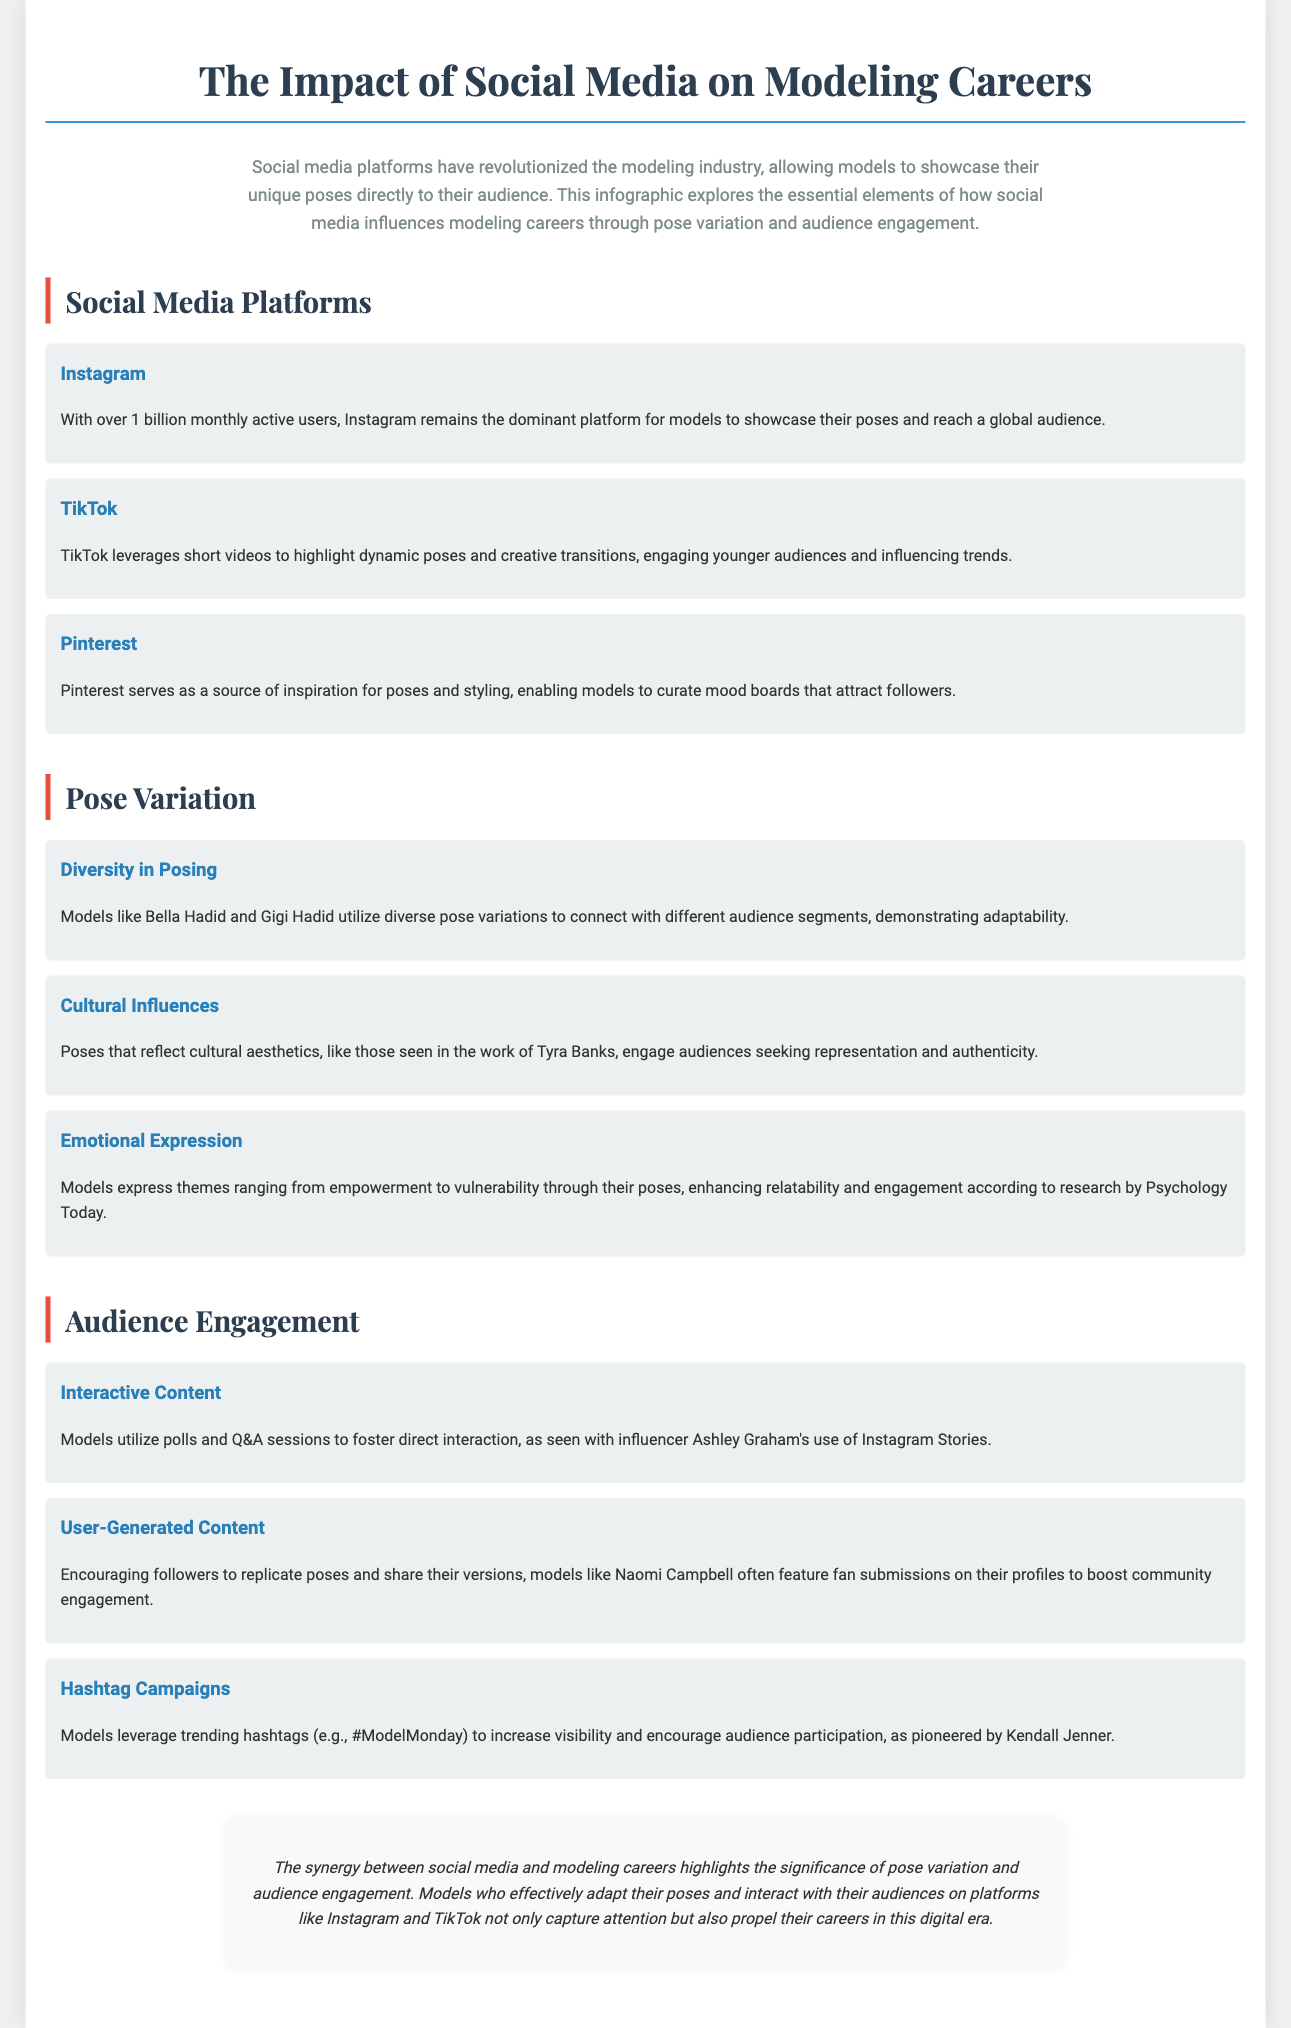what is the dominant platform for models to showcase their poses? The document states that Instagram remains the dominant platform for models with over 1 billion monthly active users.
Answer: Instagram who are two models mentioned that utilize diverse pose variations? The document mentions Bella Hadid and Gigi Hadid in the context of diverse pose variations connecting with different audience segments.
Answer: Bella Hadid and Gigi Hadid what type of content do models use to foster direct interaction? The document refers to interactive content, such as polls and Q&A sessions.
Answer: Interactive Content which model is noted for her use of Instagram Stories? The document mentions influencer Ashley Graham in the context of utilizing Instagram Stories for interaction.
Answer: Ashley Graham what hashtag is mentioned as being leveraged by models for increased visibility? The document gives the example of the hashtag #ModelMonday as used by models to boost visibility and engagement.
Answer: #ModelMonday what do models encourage followers to replicate, according to the document? The document states that models encourage followers to replicate poses.
Answer: Poses what emotion themes do models express through their poses? The document highlights themes ranging from empowerment to vulnerability as expressed through models' poses.
Answer: Empowerment and vulnerability 